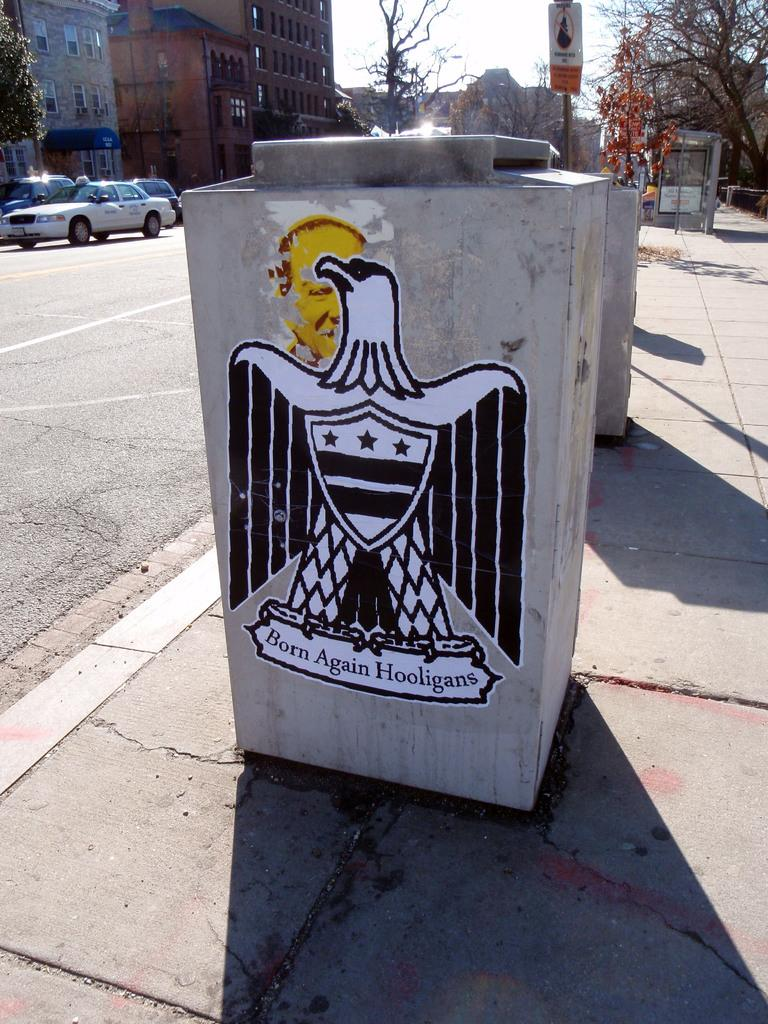<image>
Share a concise interpretation of the image provided. The word born is underneath a white eagle 